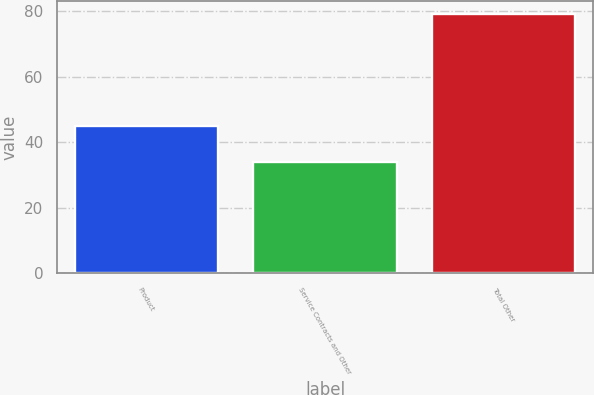Convert chart. <chart><loc_0><loc_0><loc_500><loc_500><bar_chart><fcel>Product<fcel>Service Contracts and Other<fcel>Total Other<nl><fcel>45<fcel>34<fcel>79<nl></chart> 